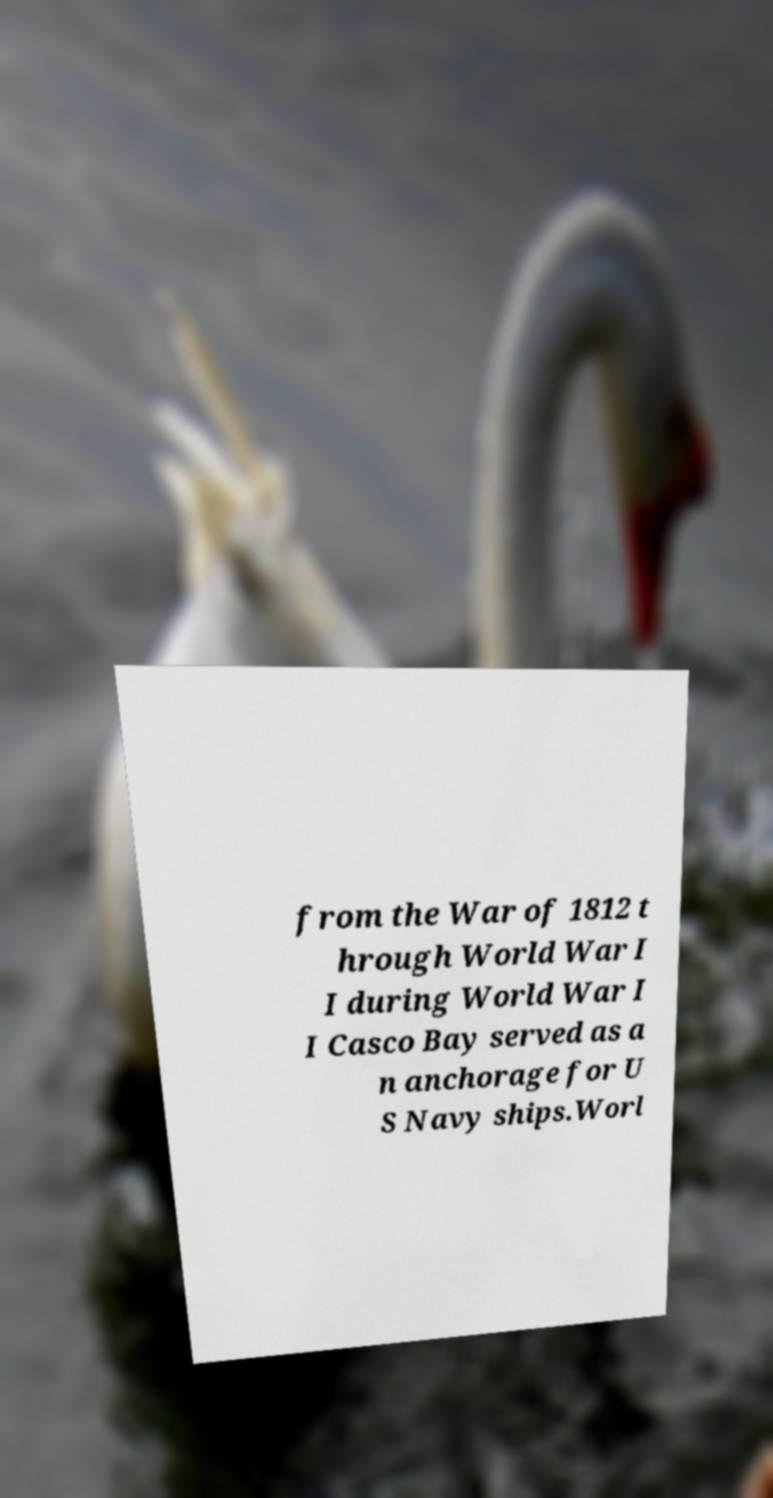Please identify and transcribe the text found in this image. from the War of 1812 t hrough World War I I during World War I I Casco Bay served as a n anchorage for U S Navy ships.Worl 